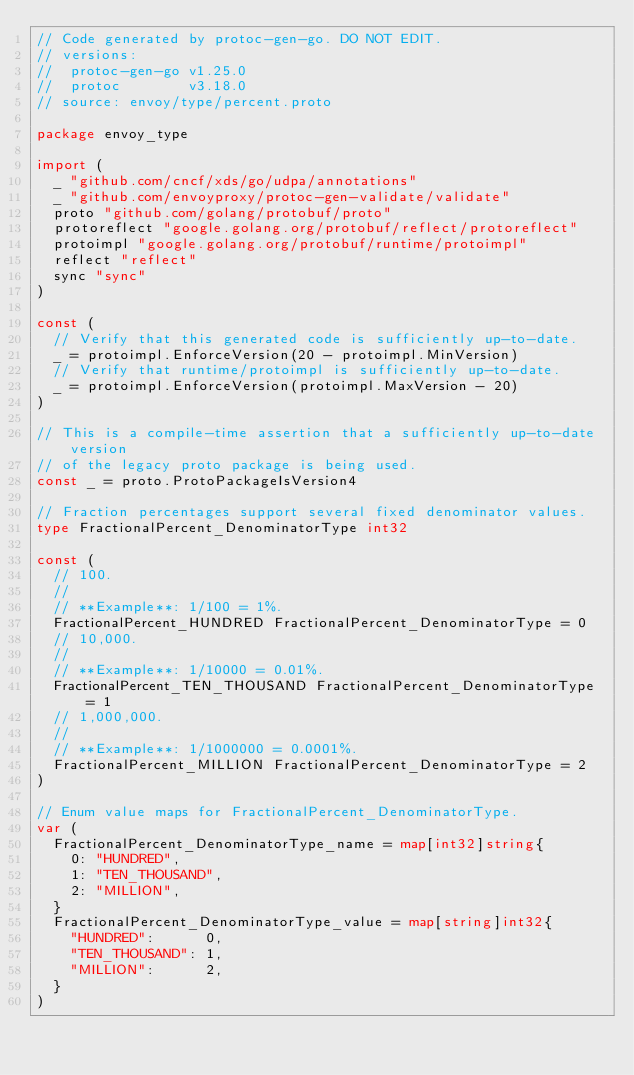<code> <loc_0><loc_0><loc_500><loc_500><_Go_>// Code generated by protoc-gen-go. DO NOT EDIT.
// versions:
// 	protoc-gen-go v1.25.0
// 	protoc        v3.18.0
// source: envoy/type/percent.proto

package envoy_type

import (
	_ "github.com/cncf/xds/go/udpa/annotations"
	_ "github.com/envoyproxy/protoc-gen-validate/validate"
	proto "github.com/golang/protobuf/proto"
	protoreflect "google.golang.org/protobuf/reflect/protoreflect"
	protoimpl "google.golang.org/protobuf/runtime/protoimpl"
	reflect "reflect"
	sync "sync"
)

const (
	// Verify that this generated code is sufficiently up-to-date.
	_ = protoimpl.EnforceVersion(20 - protoimpl.MinVersion)
	// Verify that runtime/protoimpl is sufficiently up-to-date.
	_ = protoimpl.EnforceVersion(protoimpl.MaxVersion - 20)
)

// This is a compile-time assertion that a sufficiently up-to-date version
// of the legacy proto package is being used.
const _ = proto.ProtoPackageIsVersion4

// Fraction percentages support several fixed denominator values.
type FractionalPercent_DenominatorType int32

const (
	// 100.
	//
	// **Example**: 1/100 = 1%.
	FractionalPercent_HUNDRED FractionalPercent_DenominatorType = 0
	// 10,000.
	//
	// **Example**: 1/10000 = 0.01%.
	FractionalPercent_TEN_THOUSAND FractionalPercent_DenominatorType = 1
	// 1,000,000.
	//
	// **Example**: 1/1000000 = 0.0001%.
	FractionalPercent_MILLION FractionalPercent_DenominatorType = 2
)

// Enum value maps for FractionalPercent_DenominatorType.
var (
	FractionalPercent_DenominatorType_name = map[int32]string{
		0: "HUNDRED",
		1: "TEN_THOUSAND",
		2: "MILLION",
	}
	FractionalPercent_DenominatorType_value = map[string]int32{
		"HUNDRED":      0,
		"TEN_THOUSAND": 1,
		"MILLION":      2,
	}
)
</code> 